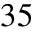Convert formula to latex. <formula><loc_0><loc_0><loc_500><loc_500>3 5</formula> 